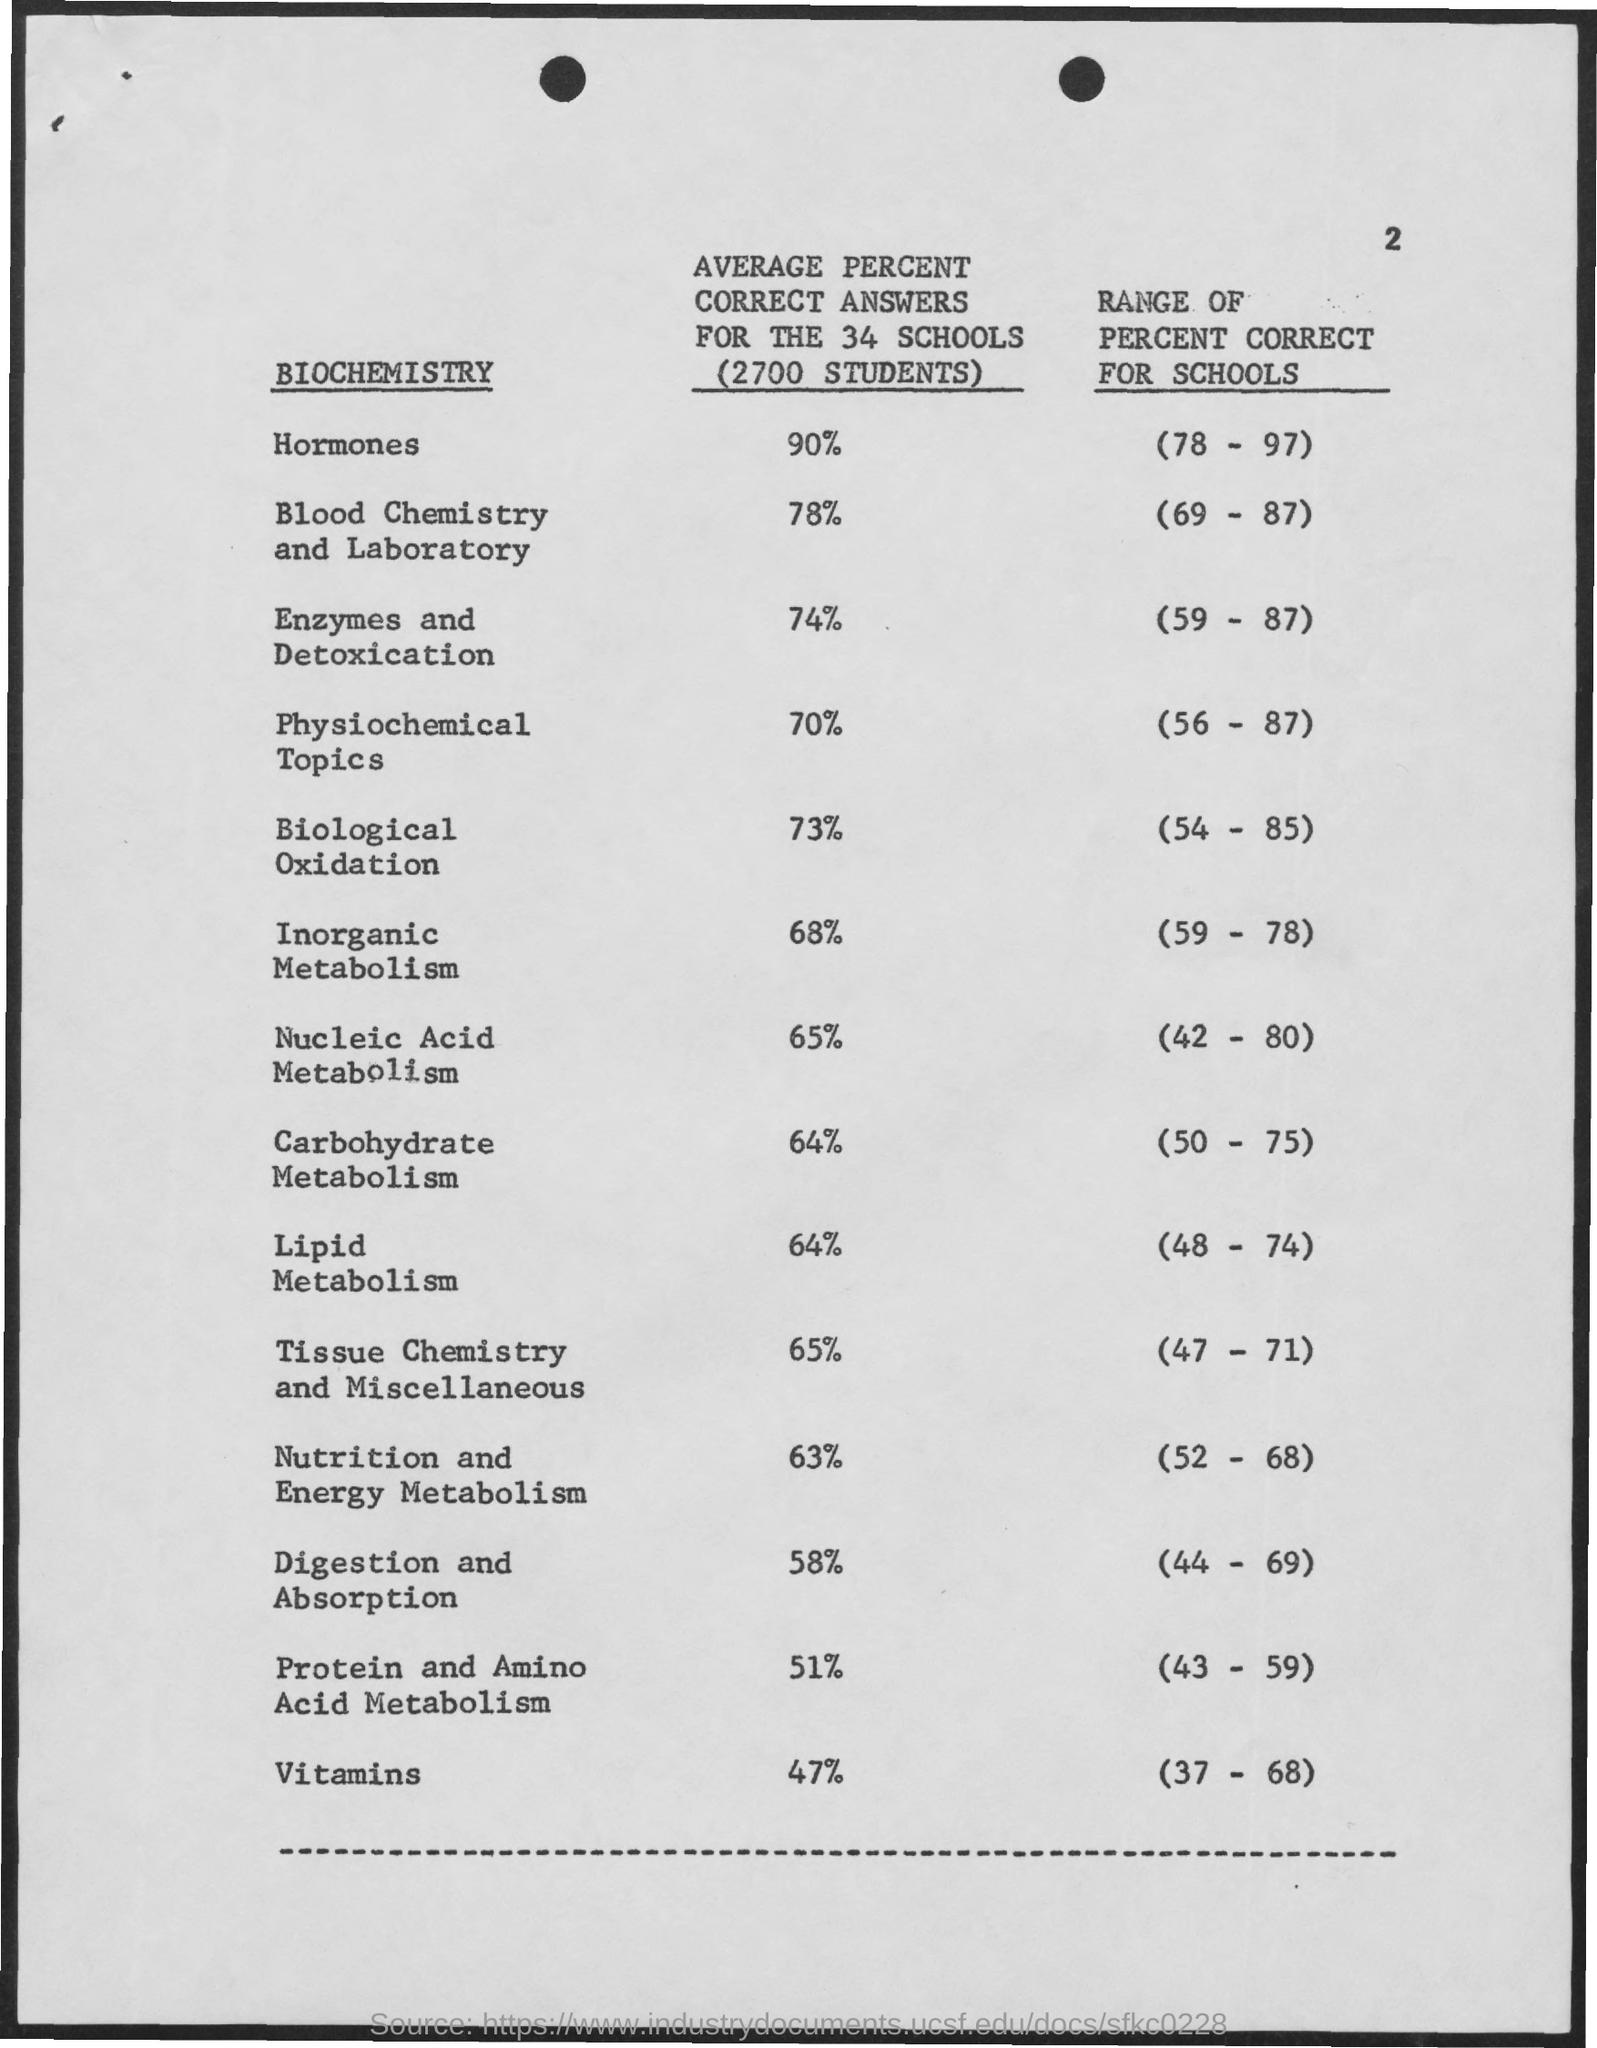Mention a couple of crucial points in this snapshot. There are approximately 2,700 students. 